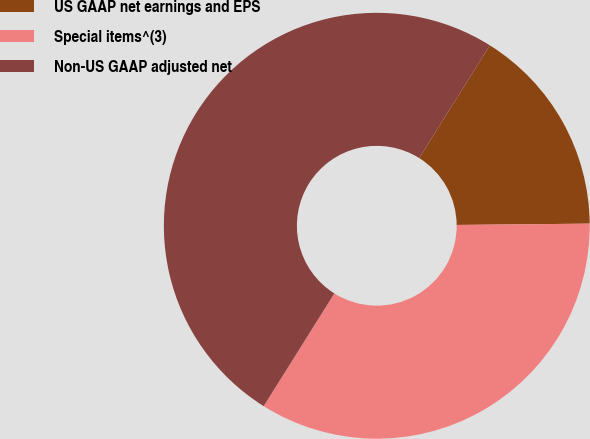Convert chart. <chart><loc_0><loc_0><loc_500><loc_500><pie_chart><fcel>US GAAP net earnings and EPS<fcel>Special items^(3)<fcel>Non-US GAAP adjusted net<nl><fcel>15.93%<fcel>34.07%<fcel>50.0%<nl></chart> 